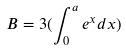Convert formula to latex. <formula><loc_0><loc_0><loc_500><loc_500>B = 3 ( \int _ { 0 } ^ { a } e ^ { x } d x )</formula> 